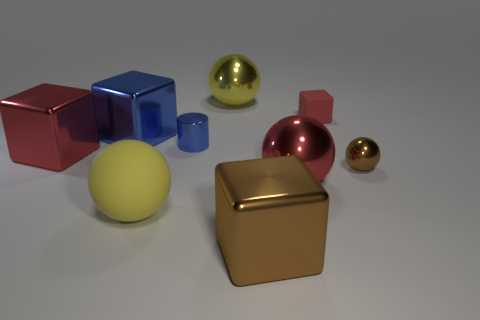How would you describe the lighting and the atmosphere of the scene? The scene is illuminated with soft, diffuse lighting that casts gentle shadows on the ground, giving the collection of objects a calm and almost surreal atmosphere. The lighting appears to be coming from above and enhances the three-dimensional look of the objects by highlighting their contours and textures. What could be the purpose of arranging these objects in this way? The arrangement might be an artistic display, a study in contrasts and comparisons that highlights the diversity of shape, size, and texture. It can also serve educational purposes, such as for teaching geometry, color theory, or photography lighting techniques. 